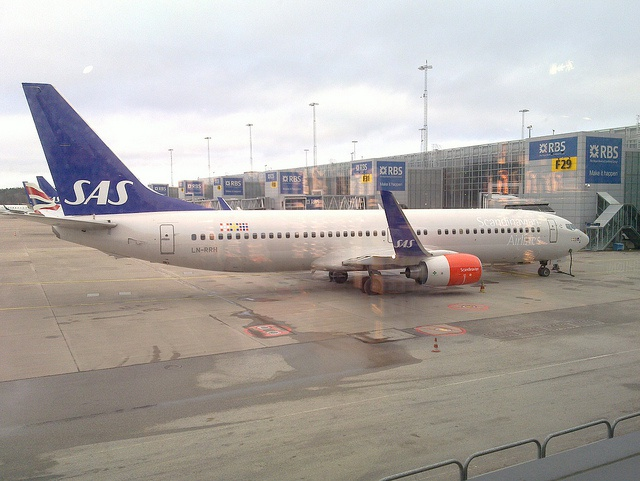Describe the objects in this image and their specific colors. I can see airplane in white, lightgray, darkgray, gray, and purple tones, airplane in white, lightgray, brown, beige, and darkgray tones, and airplane in white, gray, purple, lightgray, and darkblue tones in this image. 